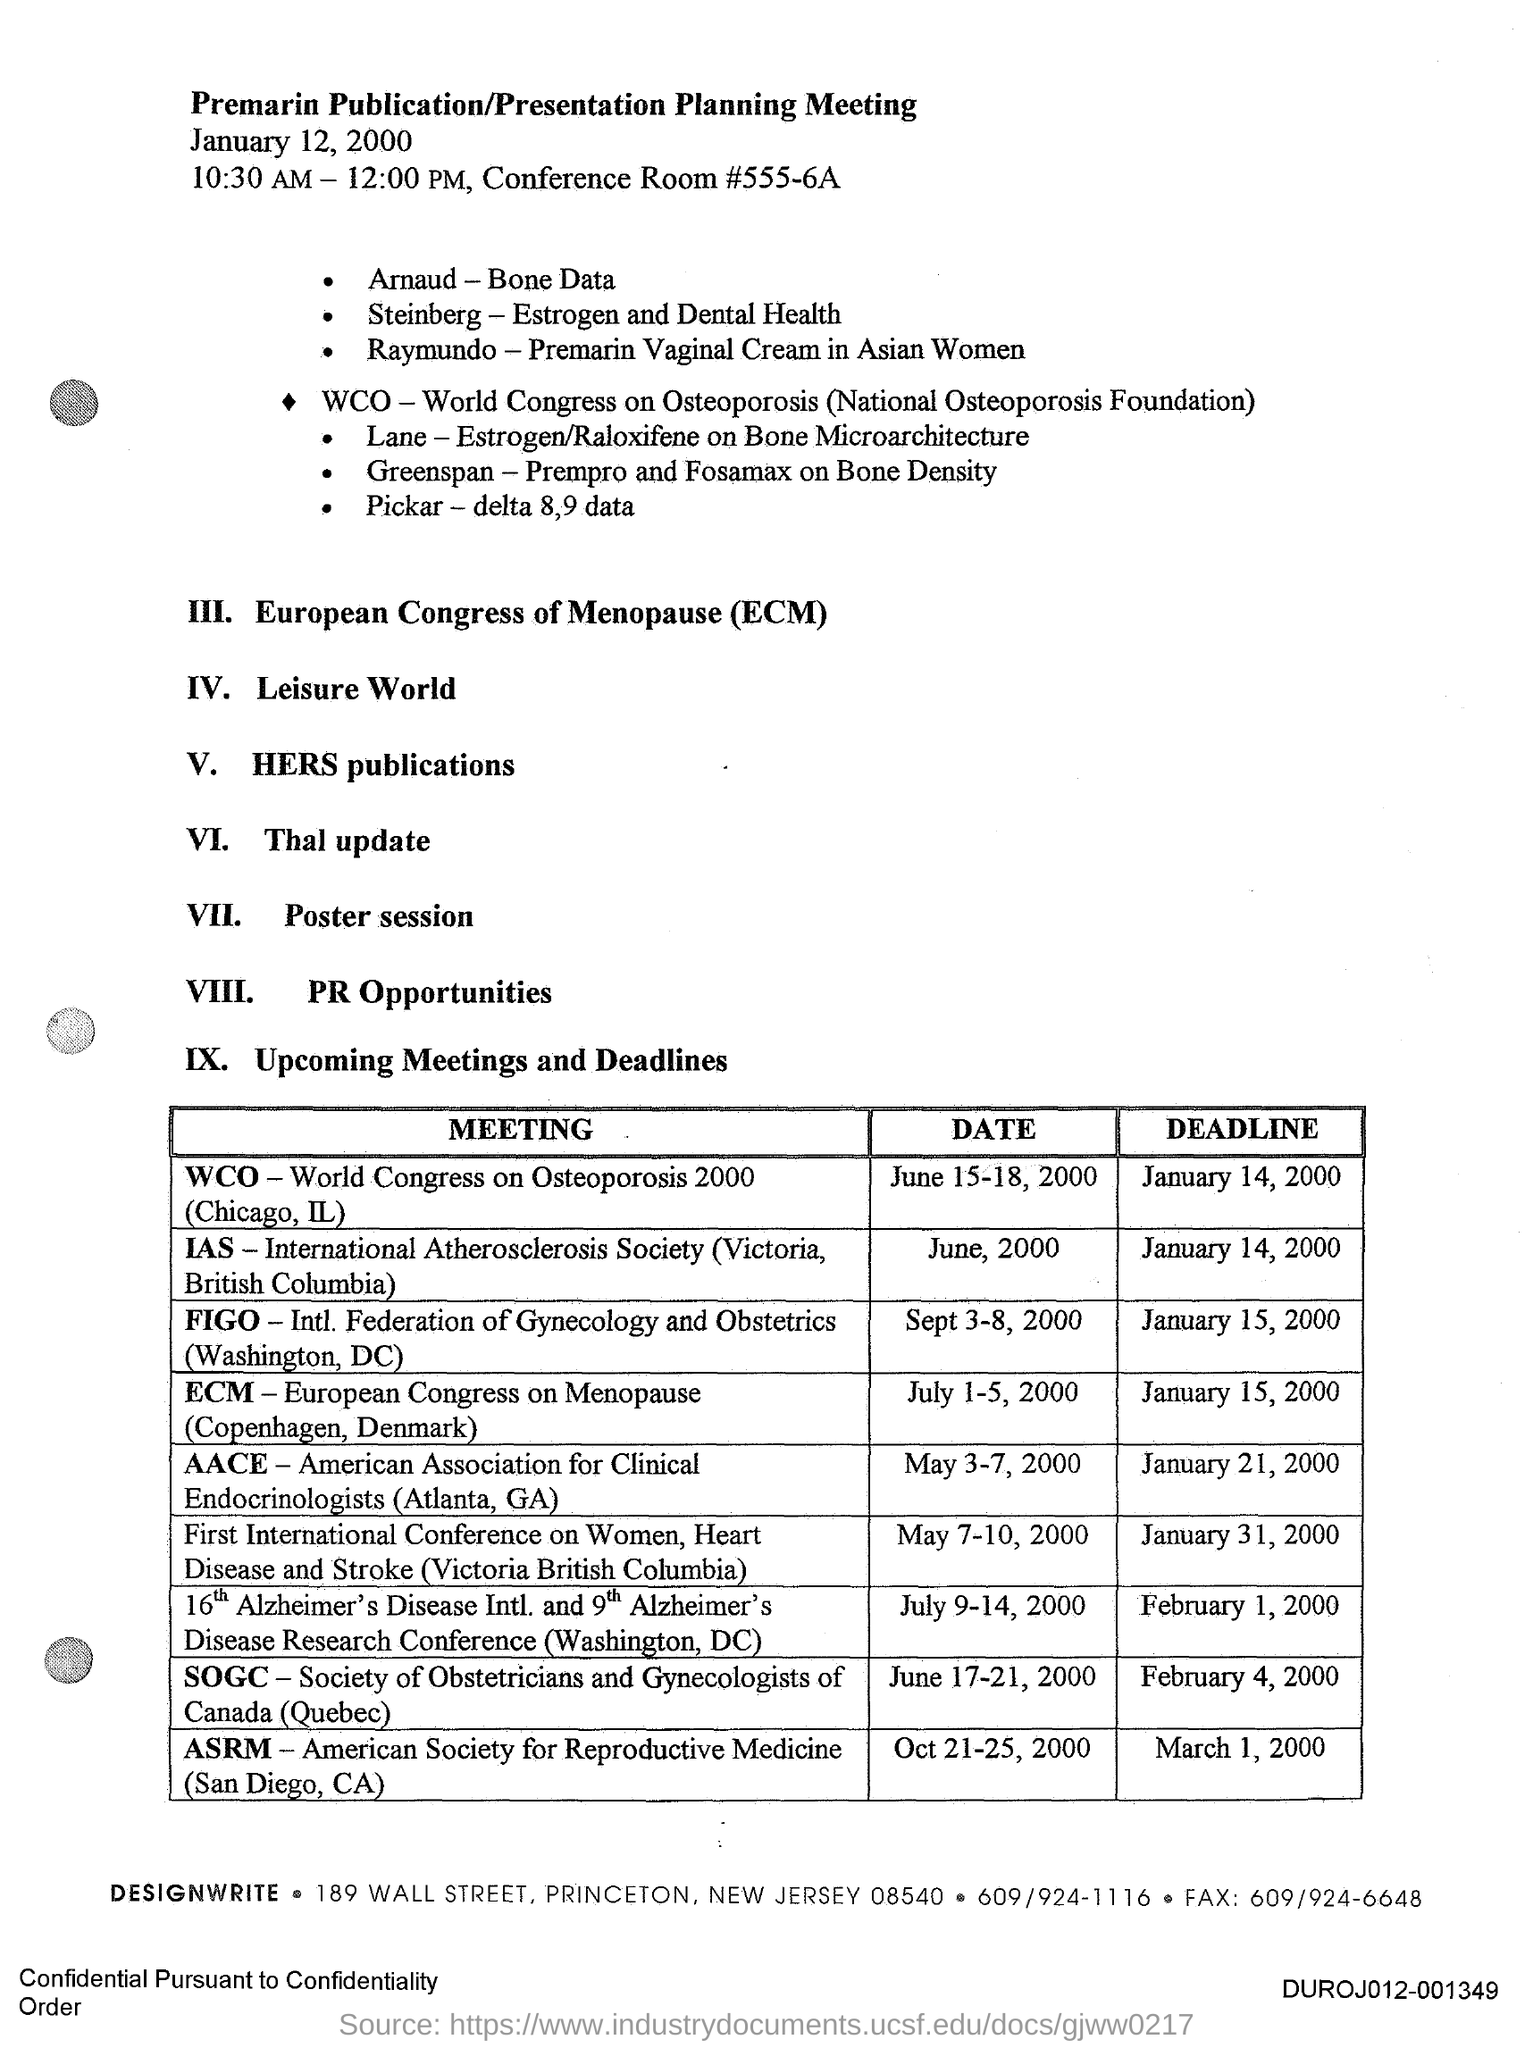When is the Premarin Publication/PresentationPlanning Meeting held?
Provide a succinct answer. January 12, 2000. What time is the Premarin Publication/PresentationPlanning Meeting held?
Ensure brevity in your answer.  10.30 AM - 12:00 PM. What is the "Date" for the "Meeting" "WCO World Congress on Osteoporosis 2000 (Chicago, IL)?
Your answer should be compact. June 15-18, 2000. What is the "Deadline" for the "Meeting" "WCO World Congress on Osteoporosis 2000 (Chicago, IL)?
Your answer should be very brief. January 14, 2000. 